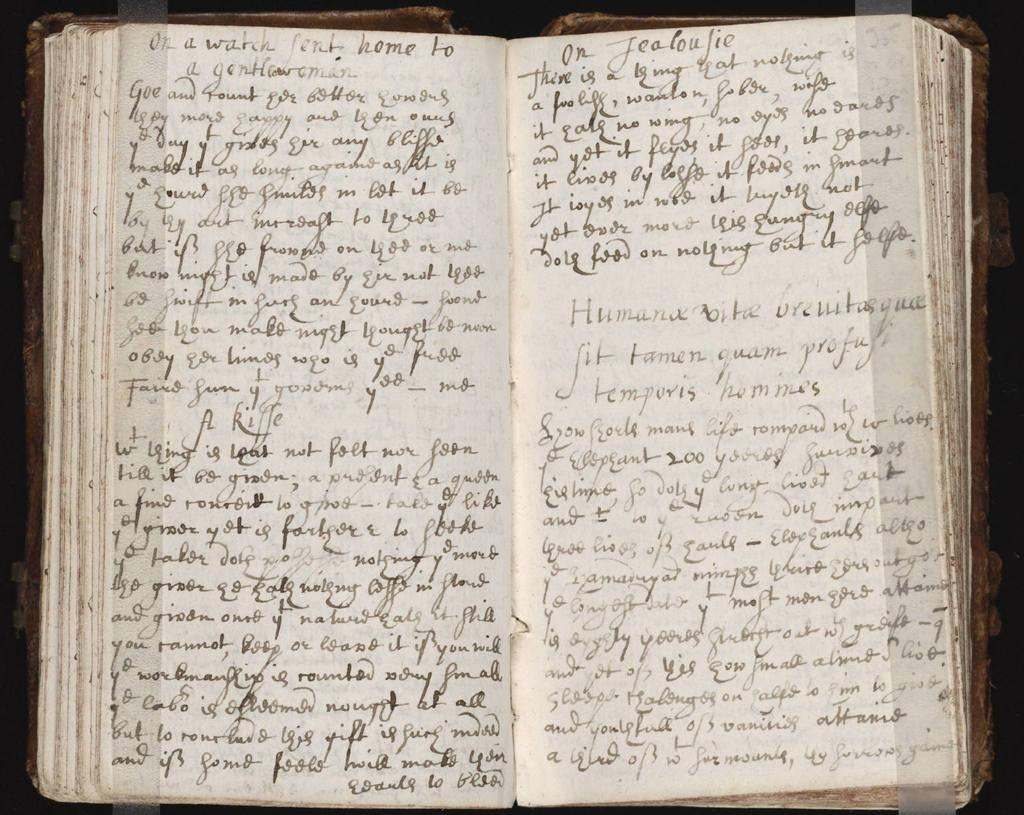<image>
Present a compact description of the photo's key features. Two pages of hand written text begin with the words On A Watch Sent Home. 